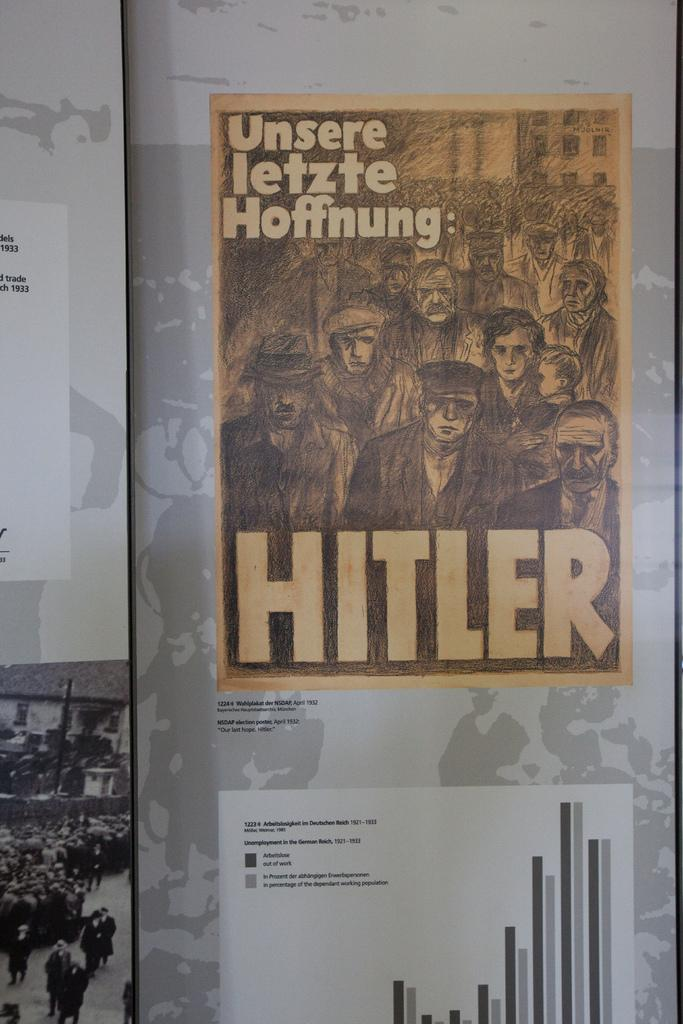<image>
Summarize the visual content of the image. A sign has Unsere letzte Hoffnug in the upper left corner and Hitler at the bottom of the page. 